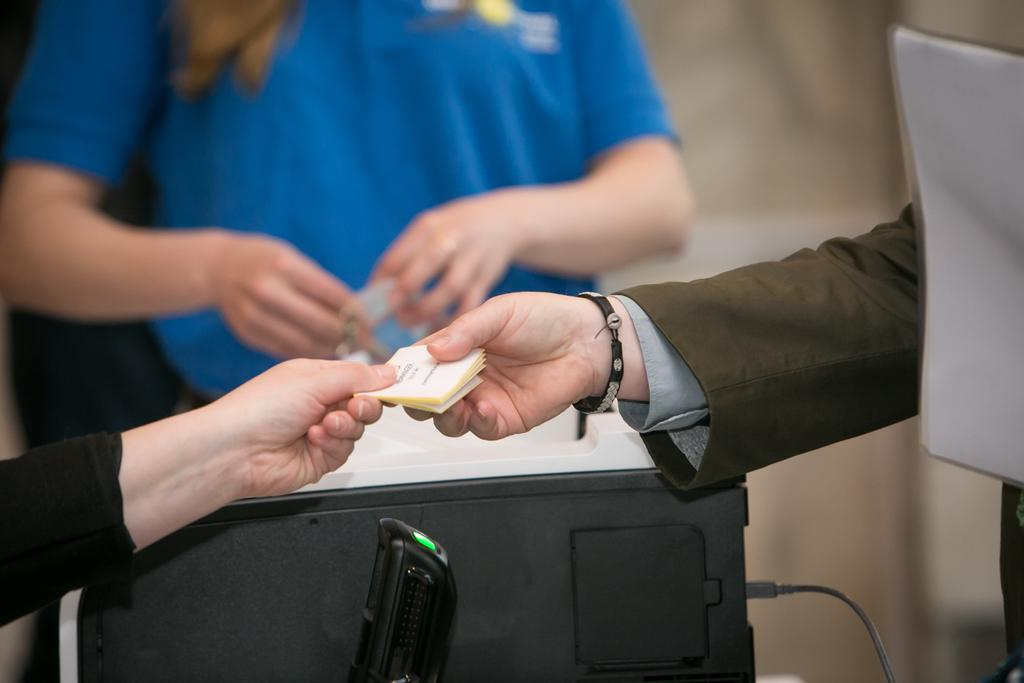What is being held by the hands in the image? There are hands holding cards in the image. What else can be seen in the image besides the cards? There is a device and a cable in the image. Can you describe the person in the image? There is a person in the image. What is the appearance of the background in the image? The background of the image is blurred. How many dogs are sitting on the fork in the image? There are no dogs or forks present in the image. 